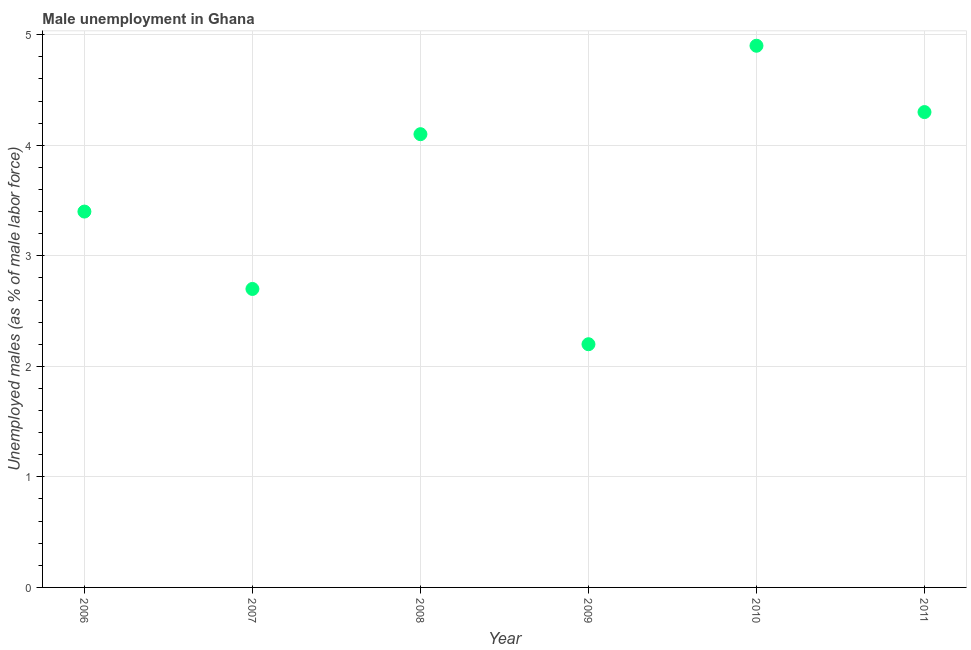What is the unemployed males population in 2008?
Offer a very short reply. 4.1. Across all years, what is the maximum unemployed males population?
Provide a succinct answer. 4.9. Across all years, what is the minimum unemployed males population?
Offer a very short reply. 2.2. In which year was the unemployed males population maximum?
Offer a terse response. 2010. In which year was the unemployed males population minimum?
Provide a short and direct response. 2009. What is the sum of the unemployed males population?
Make the answer very short. 21.6. What is the difference between the unemployed males population in 2008 and 2011?
Provide a succinct answer. -0.2. What is the average unemployed males population per year?
Keep it short and to the point. 3.6. What is the median unemployed males population?
Offer a terse response. 3.75. In how many years, is the unemployed males population greater than 2.6 %?
Give a very brief answer. 5. What is the ratio of the unemployed males population in 2007 to that in 2010?
Your response must be concise. 0.55. Is the unemployed males population in 2009 less than that in 2011?
Your answer should be very brief. Yes. Is the difference between the unemployed males population in 2006 and 2009 greater than the difference between any two years?
Offer a very short reply. No. What is the difference between the highest and the second highest unemployed males population?
Your answer should be compact. 0.6. What is the difference between the highest and the lowest unemployed males population?
Make the answer very short. 2.7. In how many years, is the unemployed males population greater than the average unemployed males population taken over all years?
Your response must be concise. 3. How many dotlines are there?
Ensure brevity in your answer.  1. What is the difference between two consecutive major ticks on the Y-axis?
Your answer should be compact. 1. Are the values on the major ticks of Y-axis written in scientific E-notation?
Your answer should be compact. No. Does the graph contain grids?
Your answer should be compact. Yes. What is the title of the graph?
Your answer should be compact. Male unemployment in Ghana. What is the label or title of the X-axis?
Make the answer very short. Year. What is the label or title of the Y-axis?
Offer a very short reply. Unemployed males (as % of male labor force). What is the Unemployed males (as % of male labor force) in 2006?
Give a very brief answer. 3.4. What is the Unemployed males (as % of male labor force) in 2007?
Keep it short and to the point. 2.7. What is the Unemployed males (as % of male labor force) in 2008?
Provide a succinct answer. 4.1. What is the Unemployed males (as % of male labor force) in 2009?
Your answer should be very brief. 2.2. What is the Unemployed males (as % of male labor force) in 2010?
Your answer should be compact. 4.9. What is the Unemployed males (as % of male labor force) in 2011?
Your answer should be very brief. 4.3. What is the difference between the Unemployed males (as % of male labor force) in 2006 and 2007?
Provide a succinct answer. 0.7. What is the difference between the Unemployed males (as % of male labor force) in 2006 and 2009?
Offer a terse response. 1.2. What is the difference between the Unemployed males (as % of male labor force) in 2006 and 2010?
Your answer should be very brief. -1.5. What is the difference between the Unemployed males (as % of male labor force) in 2007 and 2009?
Keep it short and to the point. 0.5. What is the difference between the Unemployed males (as % of male labor force) in 2007 and 2011?
Provide a succinct answer. -1.6. What is the difference between the Unemployed males (as % of male labor force) in 2008 and 2010?
Offer a terse response. -0.8. What is the difference between the Unemployed males (as % of male labor force) in 2008 and 2011?
Make the answer very short. -0.2. What is the difference between the Unemployed males (as % of male labor force) in 2010 and 2011?
Provide a succinct answer. 0.6. What is the ratio of the Unemployed males (as % of male labor force) in 2006 to that in 2007?
Your answer should be compact. 1.26. What is the ratio of the Unemployed males (as % of male labor force) in 2006 to that in 2008?
Offer a very short reply. 0.83. What is the ratio of the Unemployed males (as % of male labor force) in 2006 to that in 2009?
Your response must be concise. 1.54. What is the ratio of the Unemployed males (as % of male labor force) in 2006 to that in 2010?
Provide a short and direct response. 0.69. What is the ratio of the Unemployed males (as % of male labor force) in 2006 to that in 2011?
Offer a terse response. 0.79. What is the ratio of the Unemployed males (as % of male labor force) in 2007 to that in 2008?
Make the answer very short. 0.66. What is the ratio of the Unemployed males (as % of male labor force) in 2007 to that in 2009?
Ensure brevity in your answer.  1.23. What is the ratio of the Unemployed males (as % of male labor force) in 2007 to that in 2010?
Provide a short and direct response. 0.55. What is the ratio of the Unemployed males (as % of male labor force) in 2007 to that in 2011?
Ensure brevity in your answer.  0.63. What is the ratio of the Unemployed males (as % of male labor force) in 2008 to that in 2009?
Ensure brevity in your answer.  1.86. What is the ratio of the Unemployed males (as % of male labor force) in 2008 to that in 2010?
Give a very brief answer. 0.84. What is the ratio of the Unemployed males (as % of male labor force) in 2008 to that in 2011?
Offer a terse response. 0.95. What is the ratio of the Unemployed males (as % of male labor force) in 2009 to that in 2010?
Give a very brief answer. 0.45. What is the ratio of the Unemployed males (as % of male labor force) in 2009 to that in 2011?
Your answer should be very brief. 0.51. What is the ratio of the Unemployed males (as % of male labor force) in 2010 to that in 2011?
Provide a short and direct response. 1.14. 